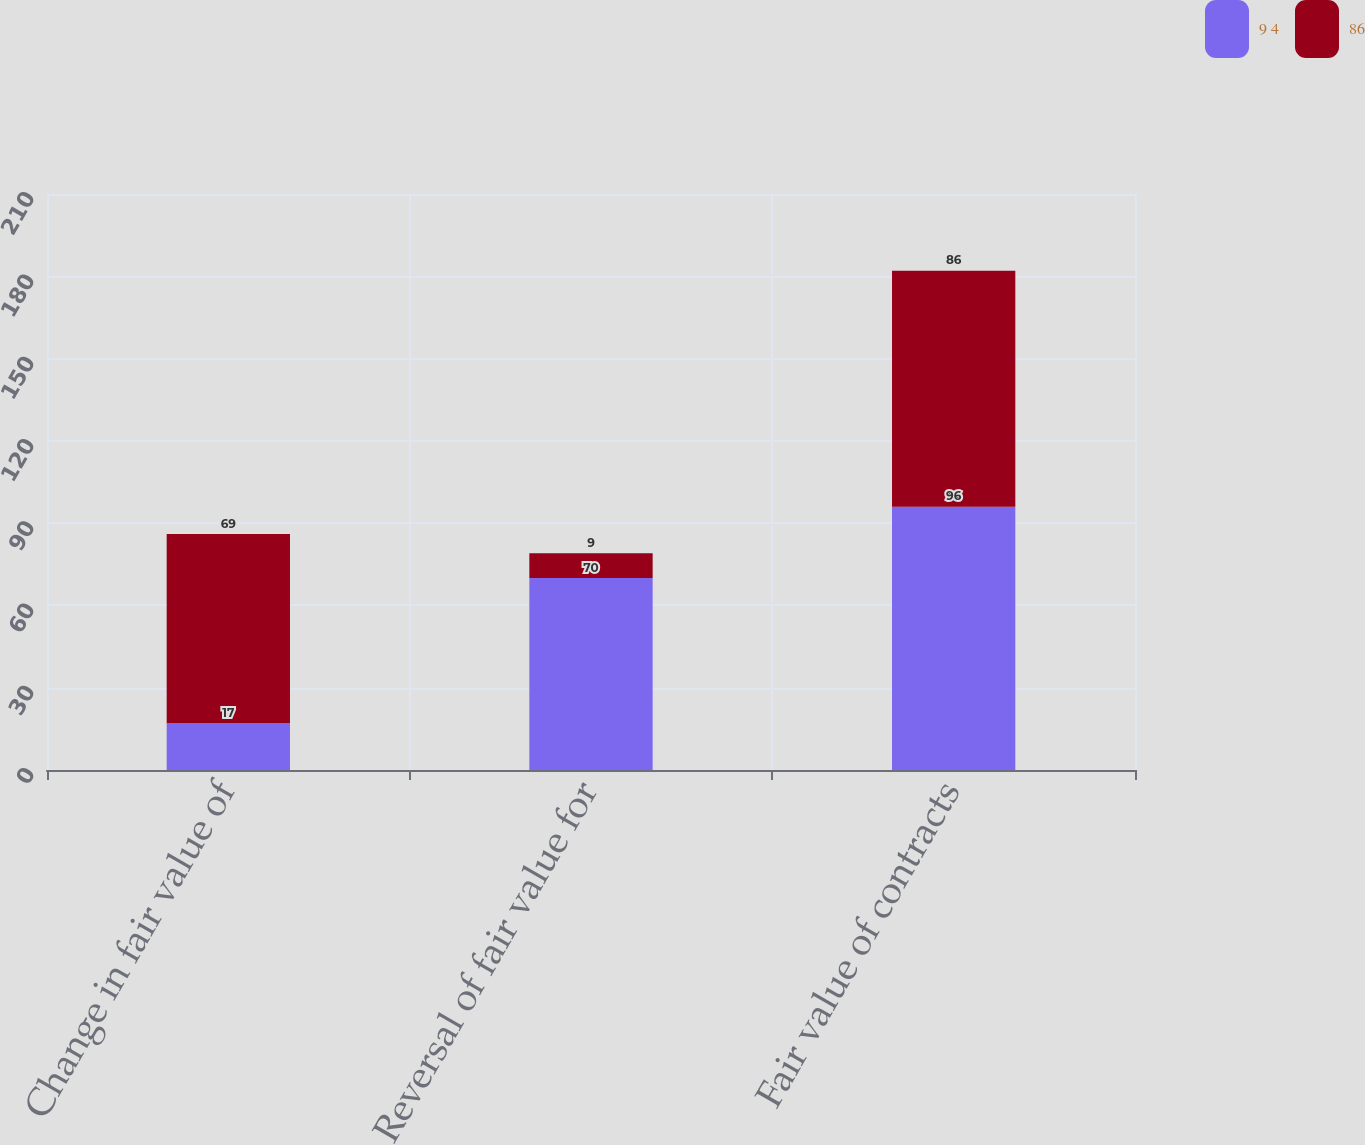<chart> <loc_0><loc_0><loc_500><loc_500><stacked_bar_chart><ecel><fcel>Change in fair value of<fcel>Reversal of fair value for<fcel>Fair value of contracts<nl><fcel>9 4<fcel>17<fcel>70<fcel>96<nl><fcel>86<fcel>69<fcel>9<fcel>86<nl></chart> 